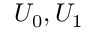Convert formula to latex. <formula><loc_0><loc_0><loc_500><loc_500>U _ { 0 } , U _ { 1 }</formula> 